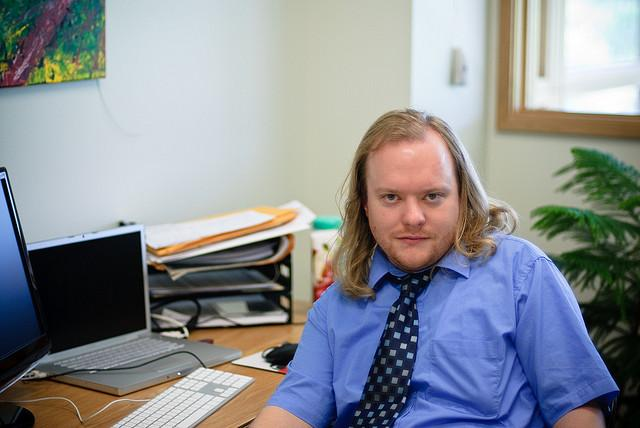What location does this man work in?

Choices:
A) clothing store
B) mall
C) office
D) stage office 